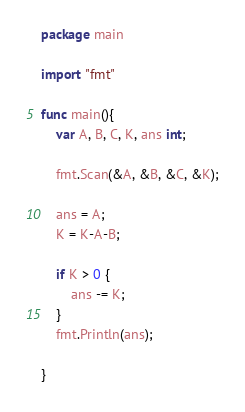Convert code to text. <code><loc_0><loc_0><loc_500><loc_500><_Go_>package main

import "fmt"

func main(){
	var A, B, C, K, ans int;

	fmt.Scan(&A, &B, &C, &K);

	ans = A;
	K = K-A-B;

	if K > 0 {
		ans -= K;
	}
	fmt.Println(ans);
	
}</code> 